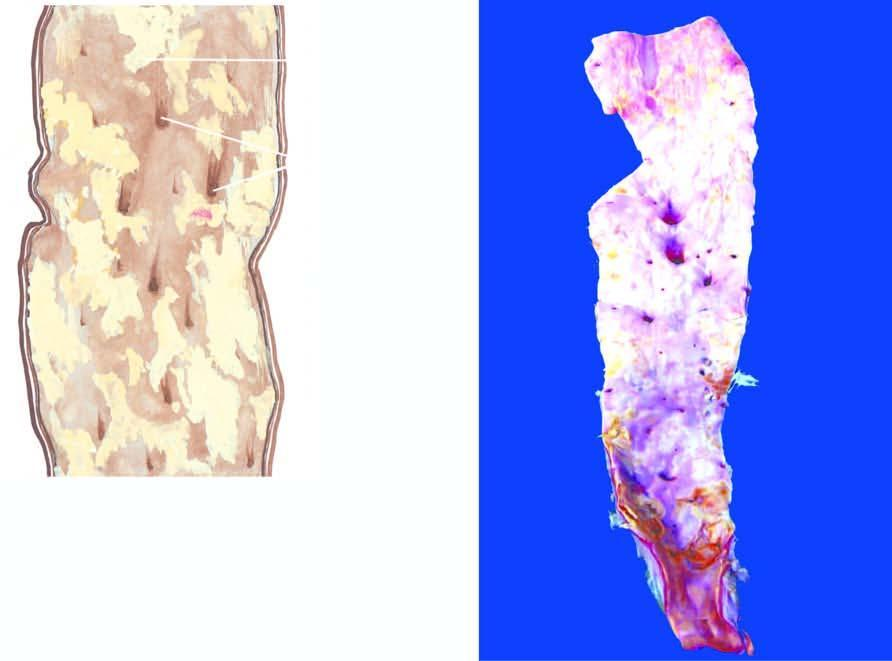do a few have ulcerated surface?
Answer the question using a single word or phrase. Yes 